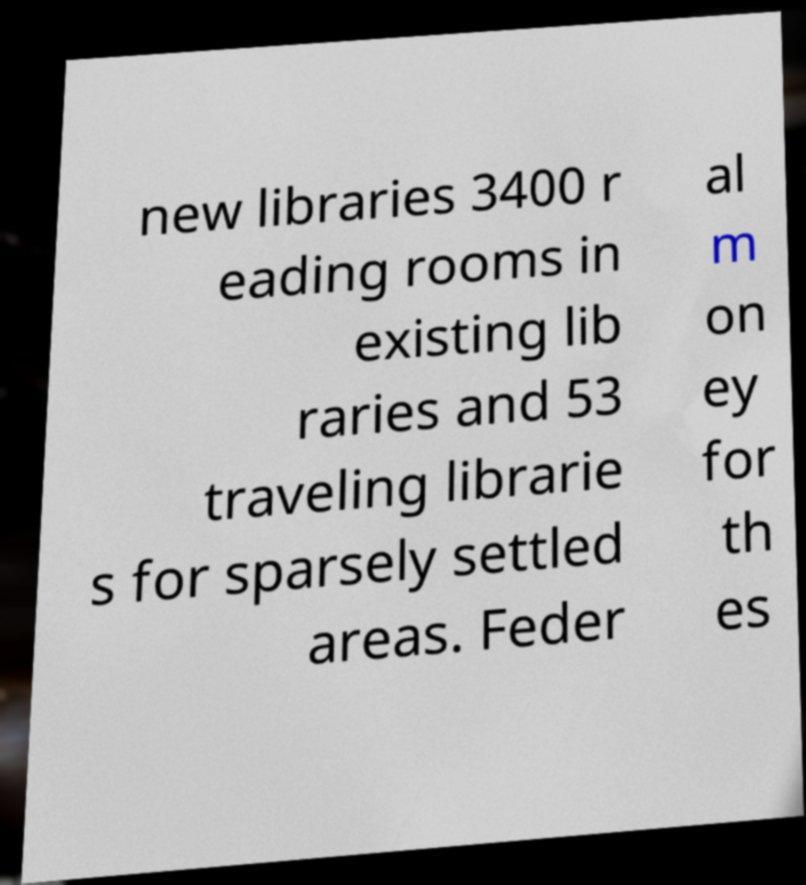Can you accurately transcribe the text from the provided image for me? new libraries 3400 r eading rooms in existing lib raries and 53 traveling librarie s for sparsely settled areas. Feder al m on ey for th es 